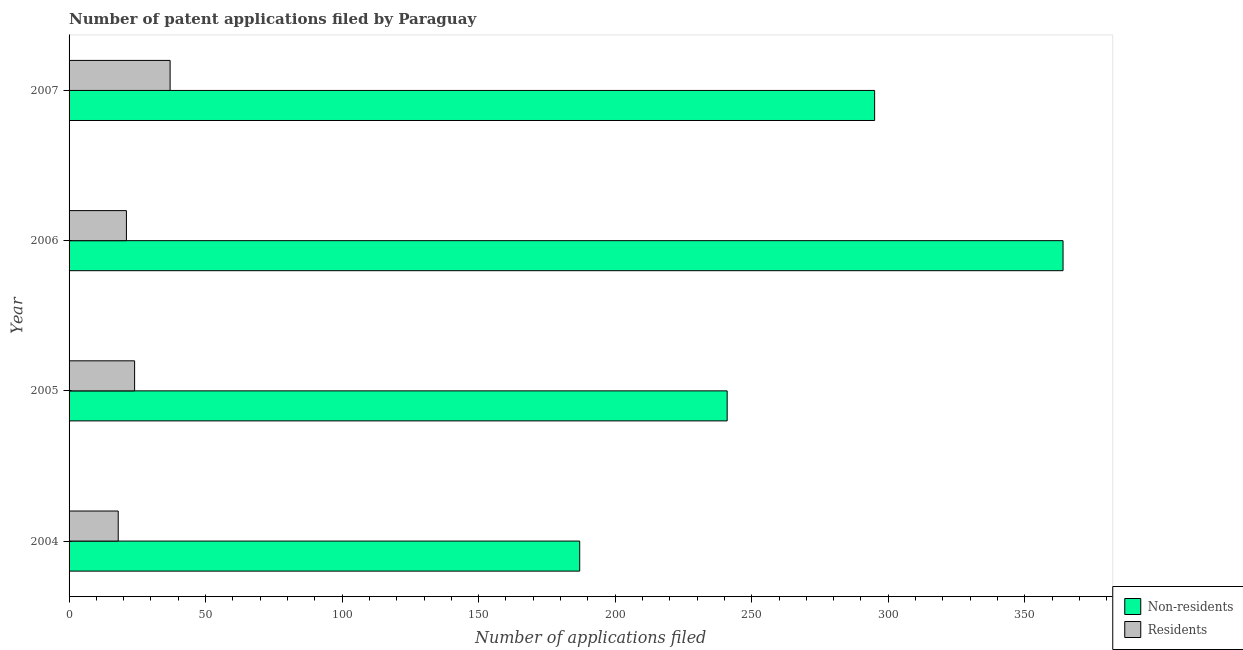How many different coloured bars are there?
Make the answer very short. 2. How many groups of bars are there?
Keep it short and to the point. 4. Are the number of bars per tick equal to the number of legend labels?
Offer a very short reply. Yes. What is the label of the 2nd group of bars from the top?
Your answer should be compact. 2006. What is the number of patent applications by residents in 2004?
Your answer should be compact. 18. Across all years, what is the maximum number of patent applications by residents?
Ensure brevity in your answer.  37. Across all years, what is the minimum number of patent applications by non residents?
Your answer should be very brief. 187. In which year was the number of patent applications by residents minimum?
Make the answer very short. 2004. What is the total number of patent applications by residents in the graph?
Give a very brief answer. 100. What is the difference between the number of patent applications by non residents in 2005 and that in 2006?
Provide a short and direct response. -123. What is the difference between the number of patent applications by non residents in 2006 and the number of patent applications by residents in 2005?
Your response must be concise. 340. What is the average number of patent applications by non residents per year?
Give a very brief answer. 271.75. In the year 2006, what is the difference between the number of patent applications by non residents and number of patent applications by residents?
Ensure brevity in your answer.  343. In how many years, is the number of patent applications by non residents greater than 80 ?
Offer a very short reply. 4. What is the ratio of the number of patent applications by non residents in 2005 to that in 2007?
Ensure brevity in your answer.  0.82. Is the number of patent applications by residents in 2004 less than that in 2005?
Your response must be concise. Yes. What is the difference between the highest and the second highest number of patent applications by non residents?
Offer a very short reply. 69. What is the difference between the highest and the lowest number of patent applications by residents?
Ensure brevity in your answer.  19. Is the sum of the number of patent applications by non residents in 2004 and 2005 greater than the maximum number of patent applications by residents across all years?
Your answer should be very brief. Yes. What does the 2nd bar from the top in 2006 represents?
Offer a terse response. Non-residents. What does the 1st bar from the bottom in 2004 represents?
Your answer should be compact. Non-residents. How many bars are there?
Make the answer very short. 8. How many years are there in the graph?
Provide a succinct answer. 4. Are the values on the major ticks of X-axis written in scientific E-notation?
Your response must be concise. No. Does the graph contain grids?
Provide a succinct answer. No. Where does the legend appear in the graph?
Give a very brief answer. Bottom right. How many legend labels are there?
Ensure brevity in your answer.  2. What is the title of the graph?
Make the answer very short. Number of patent applications filed by Paraguay. What is the label or title of the X-axis?
Offer a terse response. Number of applications filed. What is the label or title of the Y-axis?
Provide a succinct answer. Year. What is the Number of applications filed in Non-residents in 2004?
Your response must be concise. 187. What is the Number of applications filed of Non-residents in 2005?
Provide a short and direct response. 241. What is the Number of applications filed of Non-residents in 2006?
Provide a succinct answer. 364. What is the Number of applications filed of Non-residents in 2007?
Give a very brief answer. 295. What is the Number of applications filed of Residents in 2007?
Your answer should be compact. 37. Across all years, what is the maximum Number of applications filed of Non-residents?
Keep it short and to the point. 364. Across all years, what is the maximum Number of applications filed of Residents?
Offer a terse response. 37. Across all years, what is the minimum Number of applications filed of Non-residents?
Offer a terse response. 187. What is the total Number of applications filed in Non-residents in the graph?
Offer a very short reply. 1087. What is the total Number of applications filed of Residents in the graph?
Provide a succinct answer. 100. What is the difference between the Number of applications filed in Non-residents in 2004 and that in 2005?
Give a very brief answer. -54. What is the difference between the Number of applications filed of Non-residents in 2004 and that in 2006?
Keep it short and to the point. -177. What is the difference between the Number of applications filed of Non-residents in 2004 and that in 2007?
Your answer should be very brief. -108. What is the difference between the Number of applications filed in Residents in 2004 and that in 2007?
Provide a succinct answer. -19. What is the difference between the Number of applications filed in Non-residents in 2005 and that in 2006?
Offer a terse response. -123. What is the difference between the Number of applications filed of Residents in 2005 and that in 2006?
Give a very brief answer. 3. What is the difference between the Number of applications filed of Non-residents in 2005 and that in 2007?
Your response must be concise. -54. What is the difference between the Number of applications filed of Non-residents in 2004 and the Number of applications filed of Residents in 2005?
Offer a very short reply. 163. What is the difference between the Number of applications filed in Non-residents in 2004 and the Number of applications filed in Residents in 2006?
Your answer should be very brief. 166. What is the difference between the Number of applications filed in Non-residents in 2004 and the Number of applications filed in Residents in 2007?
Give a very brief answer. 150. What is the difference between the Number of applications filed of Non-residents in 2005 and the Number of applications filed of Residents in 2006?
Give a very brief answer. 220. What is the difference between the Number of applications filed of Non-residents in 2005 and the Number of applications filed of Residents in 2007?
Offer a terse response. 204. What is the difference between the Number of applications filed in Non-residents in 2006 and the Number of applications filed in Residents in 2007?
Make the answer very short. 327. What is the average Number of applications filed of Non-residents per year?
Offer a terse response. 271.75. In the year 2004, what is the difference between the Number of applications filed of Non-residents and Number of applications filed of Residents?
Your answer should be very brief. 169. In the year 2005, what is the difference between the Number of applications filed in Non-residents and Number of applications filed in Residents?
Give a very brief answer. 217. In the year 2006, what is the difference between the Number of applications filed in Non-residents and Number of applications filed in Residents?
Keep it short and to the point. 343. In the year 2007, what is the difference between the Number of applications filed in Non-residents and Number of applications filed in Residents?
Your response must be concise. 258. What is the ratio of the Number of applications filed of Non-residents in 2004 to that in 2005?
Your answer should be very brief. 0.78. What is the ratio of the Number of applications filed in Residents in 2004 to that in 2005?
Offer a terse response. 0.75. What is the ratio of the Number of applications filed in Non-residents in 2004 to that in 2006?
Your response must be concise. 0.51. What is the ratio of the Number of applications filed in Residents in 2004 to that in 2006?
Give a very brief answer. 0.86. What is the ratio of the Number of applications filed of Non-residents in 2004 to that in 2007?
Offer a very short reply. 0.63. What is the ratio of the Number of applications filed of Residents in 2004 to that in 2007?
Offer a terse response. 0.49. What is the ratio of the Number of applications filed of Non-residents in 2005 to that in 2006?
Make the answer very short. 0.66. What is the ratio of the Number of applications filed of Non-residents in 2005 to that in 2007?
Provide a succinct answer. 0.82. What is the ratio of the Number of applications filed in Residents in 2005 to that in 2007?
Offer a very short reply. 0.65. What is the ratio of the Number of applications filed of Non-residents in 2006 to that in 2007?
Provide a succinct answer. 1.23. What is the ratio of the Number of applications filed in Residents in 2006 to that in 2007?
Offer a very short reply. 0.57. What is the difference between the highest and the second highest Number of applications filed of Non-residents?
Make the answer very short. 69. What is the difference between the highest and the lowest Number of applications filed of Non-residents?
Keep it short and to the point. 177. What is the difference between the highest and the lowest Number of applications filed of Residents?
Ensure brevity in your answer.  19. 